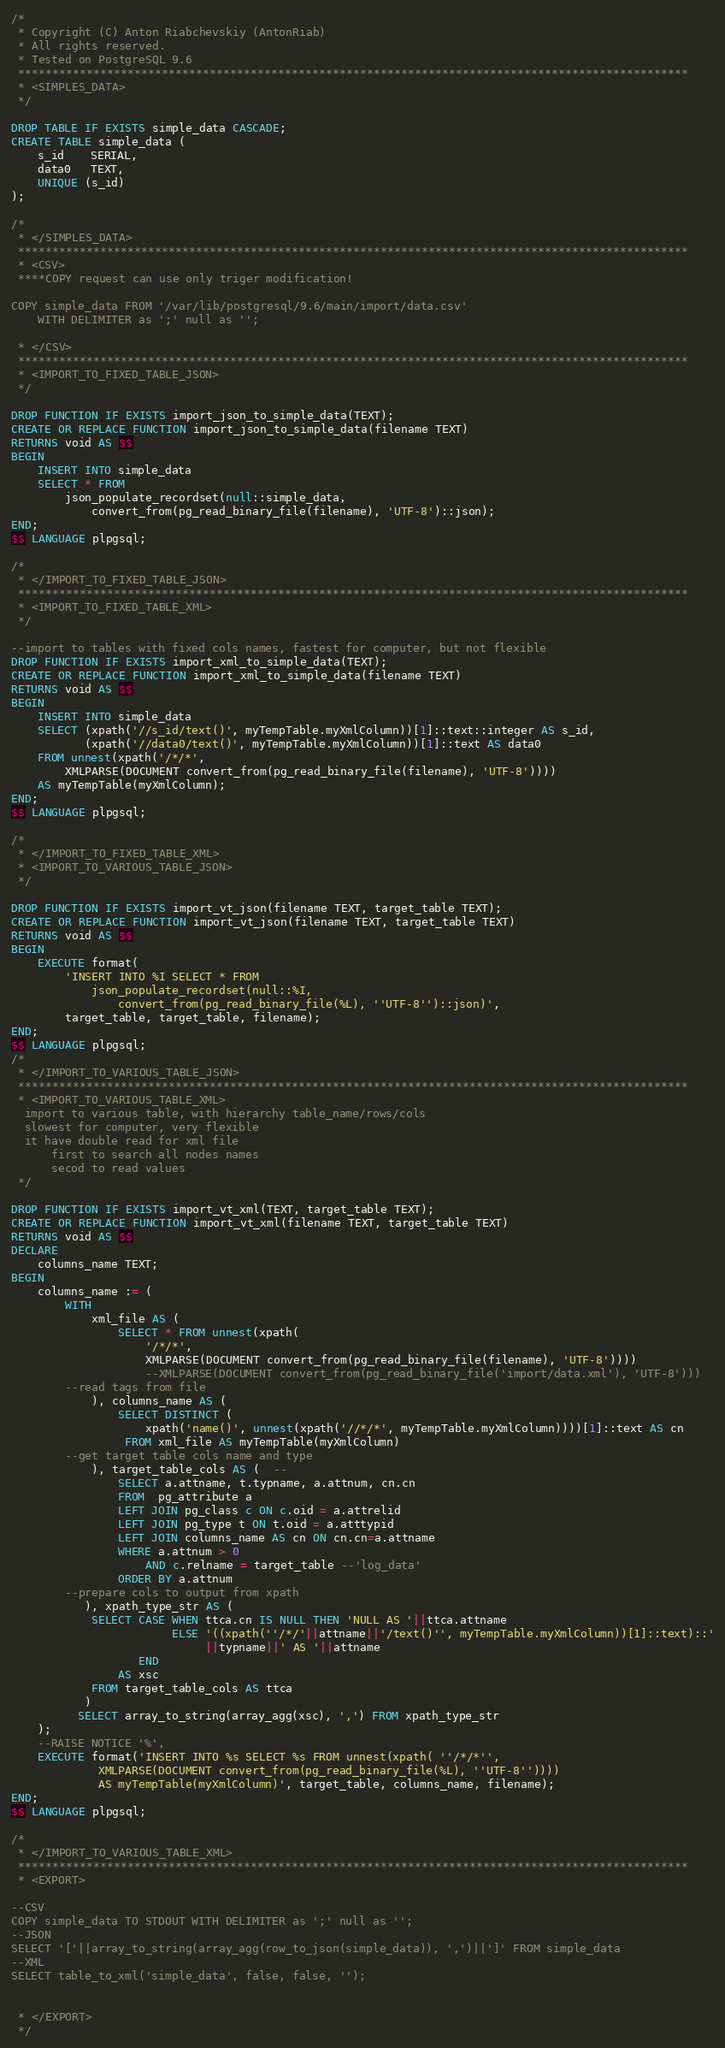<code> <loc_0><loc_0><loc_500><loc_500><_SQL_>/*
 * Copyright (C) Anton Riabchevskiy (AntonRiab)
 * All rights reserved.
 * Tested on PostgreSQL 9.6
 **************************************************************************************************
 * <SIMPLES_DATA>
 */

DROP TABLE IF EXISTS simple_data CASCADE;
CREATE TABLE simple_data (
    s_id    SERIAL,
    data0   TEXT,
    UNIQUE (s_id)
);

/*
 * </SIMPLES_DATA>
 **************************************************************************************************
 * <CSV>
 ****COPY request can use only triger modification! 

COPY simple_data FROM '/var/lib/postgresql/9.6/main/import/data.csv' 
    WITH DELIMITER as ';' null as '';

 * </CSV>
 **************************************************************************************************
 * <IMPORT_TO_FIXED_TABLE_JSON>
 */

DROP FUNCTION IF EXISTS import_json_to_simple_data(TEXT);
CREATE OR REPLACE FUNCTION import_json_to_simple_data(filename TEXT)
RETURNS void AS $$
BEGIN
    INSERT INTO simple_data
    SELECT * FROM 
        json_populate_recordset(null::simple_data, 
            convert_from(pg_read_binary_file(filename), 'UTF-8')::json);
END;
$$ LANGUAGE plpgsql;

/*
 * </IMPORT_TO_FIXED_TABLE_JSON>
 **************************************************************************************************
 * <IMPORT_TO_FIXED_TABLE_XML>
 */

--import to tables with fixed cols names, fastest for computer, but not flexible
DROP FUNCTION IF EXISTS import_xml_to_simple_data(TEXT);
CREATE OR REPLACE FUNCTION import_xml_to_simple_data(filename TEXT)
RETURNS void AS $$
BEGIN
    INSERT INTO simple_data
    SELECT (xpath('//s_id/text()', myTempTable.myXmlColumn))[1]::text::integer AS s_id,
           (xpath('//data0/text()', myTempTable.myXmlColumn))[1]::text AS data0
    FROM unnest(xpath('/*/*', 
        XMLPARSE(DOCUMENT convert_from(pg_read_binary_file(filename), 'UTF-8')))) 
    AS myTempTable(myXmlColumn);
END;
$$ LANGUAGE plpgsql;

/*
 * </IMPORT_TO_FIXED_TABLE_XML>
 * <IMPORT_TO_VARIOUS_TABLE_JSON>
 */

DROP FUNCTION IF EXISTS import_vt_json(filename TEXT, target_table TEXT);
CREATE OR REPLACE FUNCTION import_vt_json(filename TEXT, target_table TEXT)
RETURNS void AS $$
BEGIN
    EXECUTE format(
        'INSERT INTO %I SELECT * FROM 
            json_populate_recordset(null::%I, 
                convert_from(pg_read_binary_file(%L), ''UTF-8'')::json)', 
        target_table, target_table, filename);
END;
$$ LANGUAGE plpgsql;
/*
 * </IMPORT_TO_VARIOUS_TABLE_JSON>
 **************************************************************************************************
 * <IMPORT_TO_VARIOUS_TABLE_XML>
  import to various table, with hierarchy table_name/rows/cols
  slowest for computer, very flexible
  it have double read for xml file
      first to search all nodes names
      secod to read values
 */

DROP FUNCTION IF EXISTS import_vt_xml(TEXT, target_table TEXT);
CREATE OR REPLACE FUNCTION import_vt_xml(filename TEXT, target_table TEXT)
RETURNS void AS $$
DECLARE
    columns_name TEXT;
BEGIN
    columns_name := (
        WITH
            xml_file AS (
                SELECT * FROM unnest(xpath( 
                    '/*/*',
                    XMLPARSE(DOCUMENT convert_from(pg_read_binary_file(filename), 'UTF-8'))))
                    --XMLPARSE(DOCUMENT convert_from(pg_read_binary_file('import/data.xml'), 'UTF-8')))
        --read tags from file
            ), columns_name AS (
                SELECT DISTINCT (
                    xpath('name()', unnest(xpath('//*/*', myTempTable.myXmlColumn))))[1]::text AS cn
                 FROM xml_file AS myTempTable(myXmlColumn)
        --get target table cols name and type
            ), target_table_cols AS (  --
                SELECT a.attname, t.typname, a.attnum, cn.cn          
                FROM  pg_attribute a
                LEFT JOIN pg_class c ON c.oid = a.attrelid
                LEFT JOIN pg_type t ON t.oid = a.atttypid
                LEFT JOIN columns_name AS cn ON cn.cn=a.attname
                WHERE a.attnum > 0
                    AND c.relname = target_table --'log_data'
                ORDER BY a.attnum
        --prepare cols to output from xpath
           ), xpath_type_str AS (
	        SELECT CASE WHEN ttca.cn IS NULL THEN 'NULL AS '||ttca.attname 
	                    ELSE '((xpath(''/*/'||attname||'/text()'', myTempTable.myXmlColumn))[1]::text)::'
	                         ||typname||' AS '||attname
	               END 
	            AS xsc
	        FROM target_table_cols AS ttca
           )
          SELECT array_to_string(array_agg(xsc), ',') FROM xpath_type_str
    );
    --RAISE NOTICE '%',
    EXECUTE format('INSERT INTO %s SELECT %s FROM unnest(xpath( ''/*/*'',
             XMLPARSE(DOCUMENT convert_from(pg_read_binary_file(%L), ''UTF-8'')))) 
             AS myTempTable(myXmlColumn)', target_table, columns_name, filename);
END;
$$ LANGUAGE plpgsql;

/*
 * </IMPORT_TO_VARIOUS_TABLE_XML>
 **************************************************************************************************
 * <EXPORT>

--CSV
COPY simple_data TO STDOUT WITH DELIMITER as ';' null as '';
--JSON
SELECT '['||array_to_string(array_agg(row_to_json(simple_data)), ',')||']' FROM simple_data 
--XML
SELECT table_to_xml('simple_data', false, false, '');


 * </EXPORT>
 */

</code> 